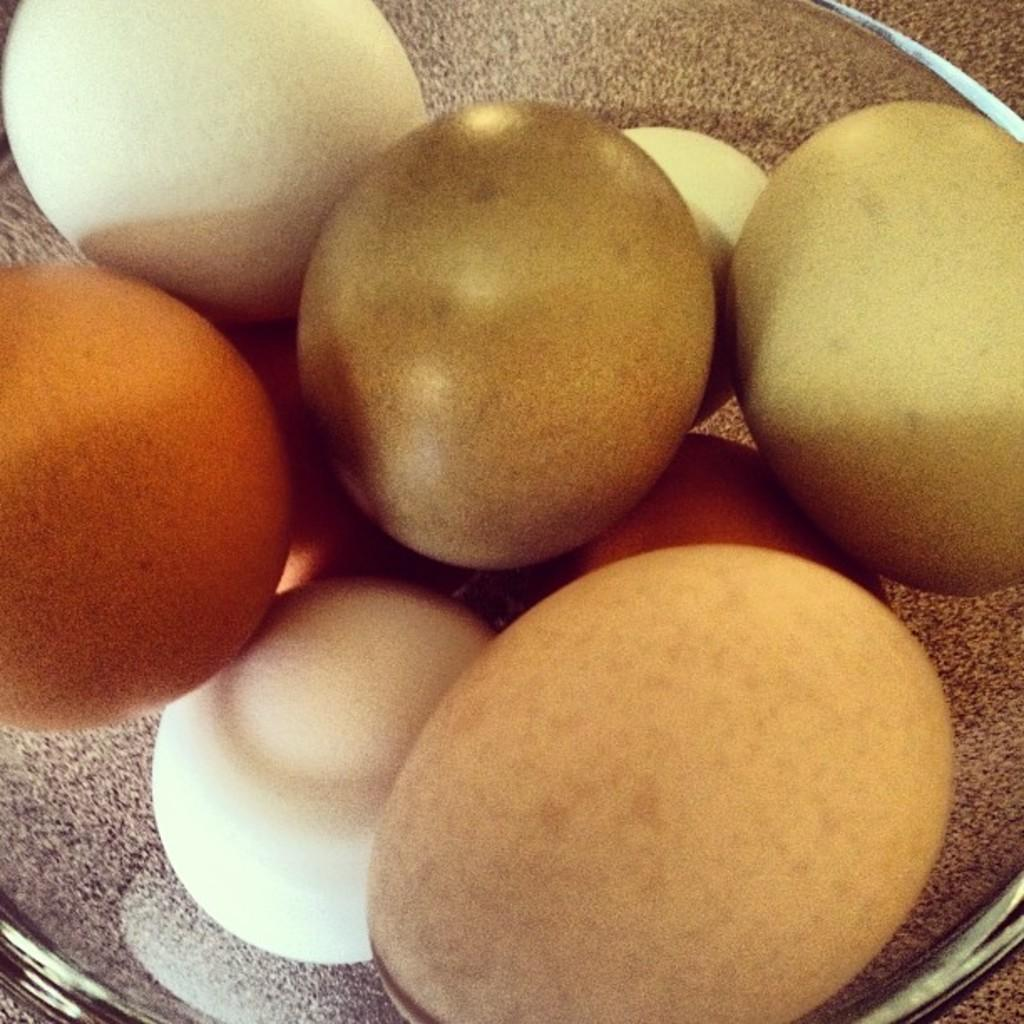What objects are present in the image? There are eggs in the image. Where are the eggs located? The eggs are in a bowl. What is the condition of the downtown area in the image? There is no downtown area present in the image; it only features eggs in a bowl. 